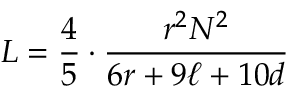<formula> <loc_0><loc_0><loc_500><loc_500>L = { \frac { 4 } { 5 } } \cdot { \frac { r ^ { 2 } N ^ { 2 } } { 6 r + 9 \ell + 1 0 d } }</formula> 